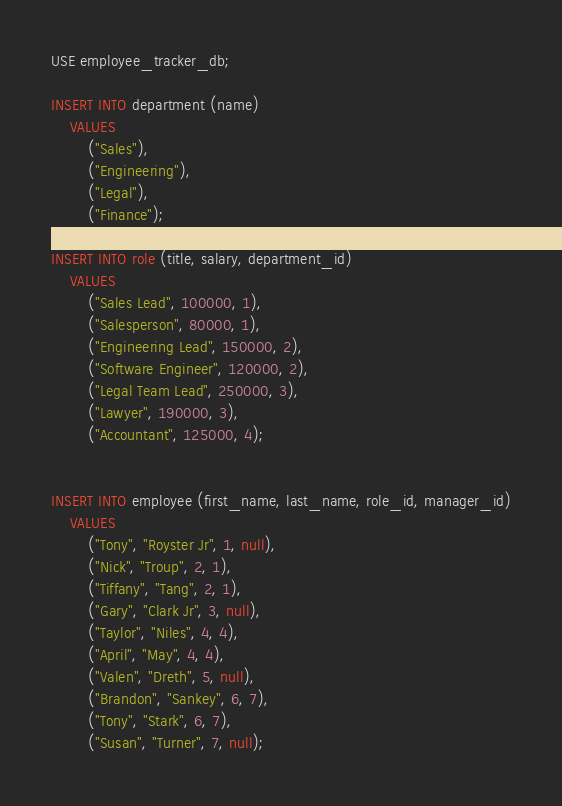Convert code to text. <code><loc_0><loc_0><loc_500><loc_500><_SQL_>USE employee_tracker_db;

INSERT INTO department (name)
	VALUES
		("Sales"),
        ("Engineering"),
        ("Legal"),
        ("Finance");
        
INSERT INTO role (title, salary, department_id)
	VALUES
		("Sales Lead", 100000, 1),
        ("Salesperson", 80000, 1),
        ("Engineering Lead", 150000, 2),
        ("Software Engineer", 120000, 2),
        ("Legal Team Lead", 250000, 3),
        ("Lawyer", 190000, 3),
        ("Accountant", 125000, 4);

        
INSERT INTO employee (first_name, last_name, role_id, manager_id)
	VALUES 
		("Tony", "Royster Jr", 1, null),
        ("Nick", "Troup", 2, 1),
		("Tiffany", "Tang", 2, 1),
		("Gary", "Clark Jr", 3, null),
        ("Taylor", "Niles", 4, 4),
        ("April", "May", 4, 4),
        ("Valen", "Dreth", 5, null),
        ("Brandon", "Sankey", 6, 7),
        ("Tony", "Stark", 6, 7),
        ("Susan", "Turner", 7, null);</code> 